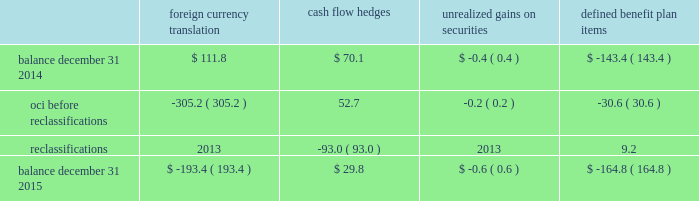Zimmer biomet holdings , inc .
2015 form 10-k annual report notes to consolidated financial statements ( continued ) interest to the date of redemption .
In addition , the merger notes and the 3.375% ( 3.375 % ) senior notes due 2021 may be redeemed at our option without any make-whole premium at specified dates ranging from one month to six months in advance of the scheduled maturity date .
Between the closing date and june 30 , 2015 , we repaid the biomet senior notes we assumed in the merger .
The fair value of the principal amount plus interest was $ 2798.6 million .
These senior notes required us to pay a call premium in excess of the fair value of the notes when they were repaid .
As a result , we recognized $ 22.0 million in non-operating other expense related to this call premium .
The estimated fair value of our senior notes as of december 31 , 2015 , based on quoted prices for the specific securities from transactions in over-the-counter markets ( level 2 ) , was $ 8837.5 million .
The estimated fair value of the japan term loan as of december 31 , 2015 , based upon publicly available market yield curves and the terms of the debt ( level 2 ) , was $ 96.4 million .
The carrying value of the u.s .
Term loan approximates fair value as it bears interest at short-term variable market rates .
We have entered into interest rate swap agreements which we designated as fair value hedges of underlying fixed- rate obligations on our senior notes due 2019 and 2021 .
See note 14 for additional information regarding the interest rate swap agreements .
We also have available uncommitted credit facilities totaling $ 35.8 million .
At december 31 , 2015 and 2014 , the weighted average interest rate for our long-term borrowings was 2.9 percent and 3.5 percent , respectively .
We paid $ 207.1 million , $ 67.5 million and $ 68.1 million in interest during 2015 , 2014 and 2013 , respectively .
13 .
Accumulated other comprehensive ( loss ) income oci refers to certain gains and losses that under gaap are included in comprehensive income but are excluded from net earnings as these amounts are initially recorded as an adjustment to stockholders 2019 equity .
Amounts in oci may be reclassified to net earnings upon the occurrence of certain events .
Our oci is comprised of foreign currency translation adjustments , unrealized gains and losses on cash flow hedges , unrealized gains and losses on available-for-sale securities , and amortization of prior service costs and unrecognized gains and losses in actuarial assumptions on our defined benefit plans .
Foreign currency translation adjustments are reclassified to net earnings upon sale or upon a complete or substantially complete liquidation of an investment in a foreign entity .
Unrealized gains and losses on cash flow hedges are reclassified to net earnings when the hedged item affects net earnings .
Unrealized gains and losses on available-for-sale securities are reclassified to net earnings if we sell the security before maturity or if the unrealized loss is considered to be other-than-temporary .
Amounts related to defined benefit plans that are in oci are reclassified over the service periods of employees in the plan .
The reclassification amounts are allocated to all employees in the plans and , therefore , the reclassified amounts may become part of inventory to the extent they are considered direct labor costs .
See note 15 for more information on our defined benefit plans .
The table shows the changes in the components of oci , net of tax ( in millions ) : foreign currency translation hedges unrealized gains on securities defined benefit .

What was total oci at december 31 , 2015 in millions? 
Computations: (((29.8 + -193.4) + -0.6) + -164.8)
Answer: -329.0. 